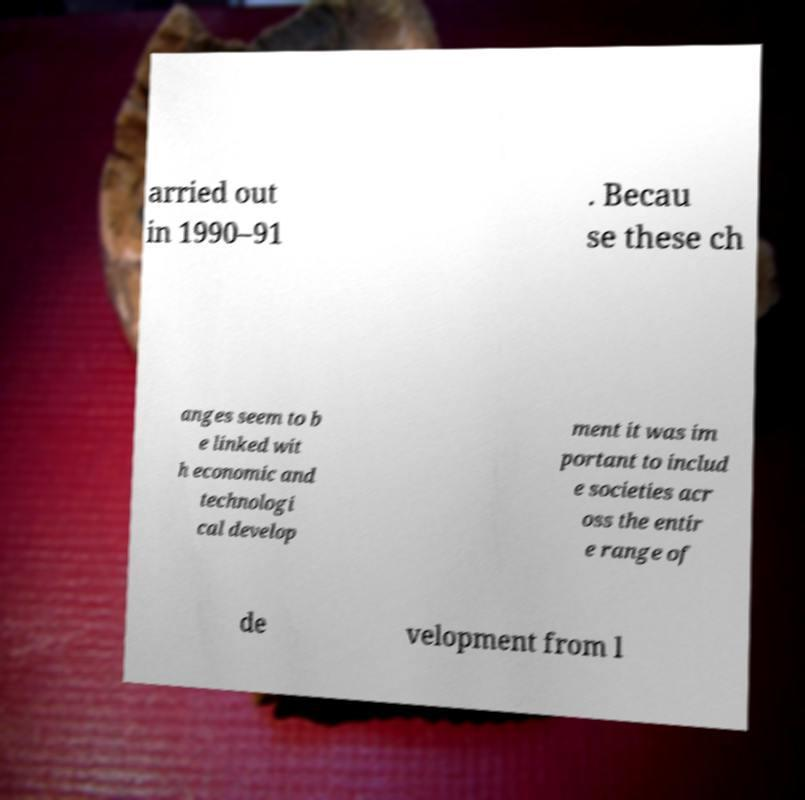There's text embedded in this image that I need extracted. Can you transcribe it verbatim? arried out in 1990–91 . Becau se these ch anges seem to b e linked wit h economic and technologi cal develop ment it was im portant to includ e societies acr oss the entir e range of de velopment from l 